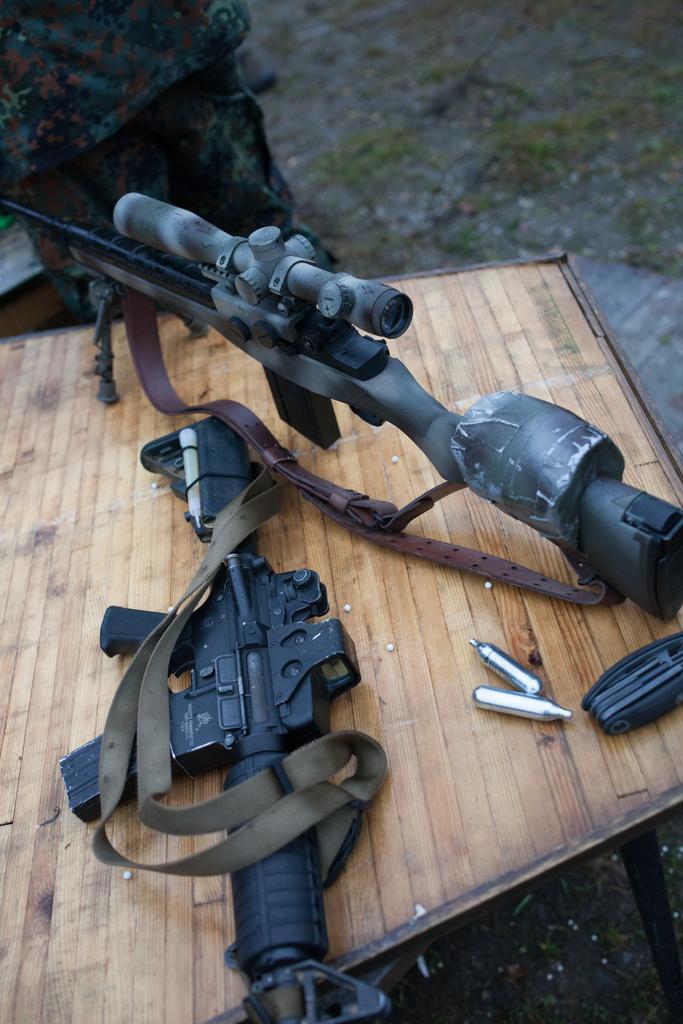In one or two sentences, can you explain what this image depicts? In this picture we can observe two guns placed on the wooden table. One of them is in black color. In the background we can observe land. 